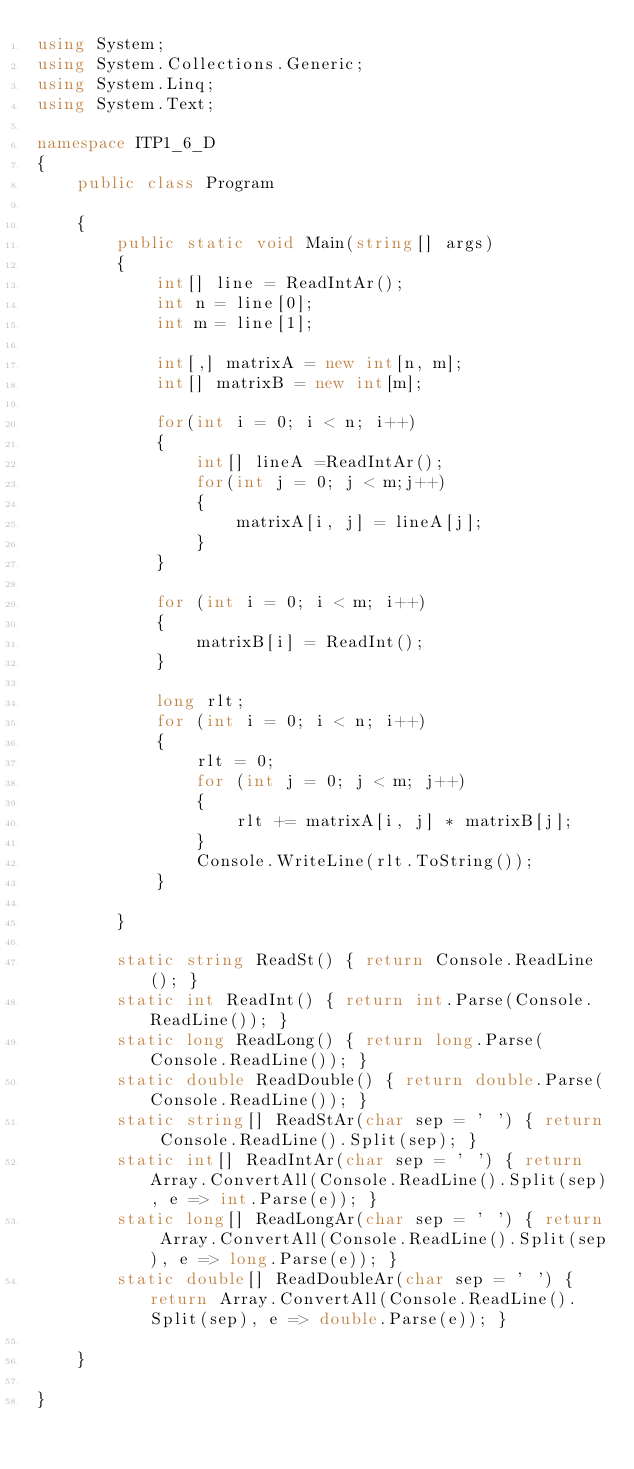<code> <loc_0><loc_0><loc_500><loc_500><_C#_>using System;
using System.Collections.Generic;
using System.Linq;
using System.Text;

namespace ITP1_6_D
{
    public class Program

    {
        public static void Main(string[] args)
        {
            int[] line = ReadIntAr();
            int n = line[0];
            int m = line[1];

            int[,] matrixA = new int[n, m];
            int[] matrixB = new int[m];

            for(int i = 0; i < n; i++)
            {
                int[] lineA =ReadIntAr();
                for(int j = 0; j < m;j++)
                {
                    matrixA[i, j] = lineA[j];
                }
            }

            for (int i = 0; i < m; i++)
            {
                matrixB[i] = ReadInt();
            }

            long rlt;
            for (int i = 0; i < n; i++)
            {
                rlt = 0;
                for (int j = 0; j < m; j++)
                {
                    rlt += matrixA[i, j] * matrixB[j];
                }
                Console.WriteLine(rlt.ToString());
            }
         
        }

        static string ReadSt() { return Console.ReadLine(); }
        static int ReadInt() { return int.Parse(Console.ReadLine()); }
        static long ReadLong() { return long.Parse(Console.ReadLine()); }
        static double ReadDouble() { return double.Parse(Console.ReadLine()); }
        static string[] ReadStAr(char sep = ' ') { return Console.ReadLine().Split(sep); }
        static int[] ReadIntAr(char sep = ' ') { return Array.ConvertAll(Console.ReadLine().Split(sep), e => int.Parse(e)); }
        static long[] ReadLongAr(char sep = ' ') { return Array.ConvertAll(Console.ReadLine().Split(sep), e => long.Parse(e)); }
        static double[] ReadDoubleAr(char sep = ' ') { return Array.ConvertAll(Console.ReadLine().Split(sep), e => double.Parse(e)); }

    }

}

</code> 